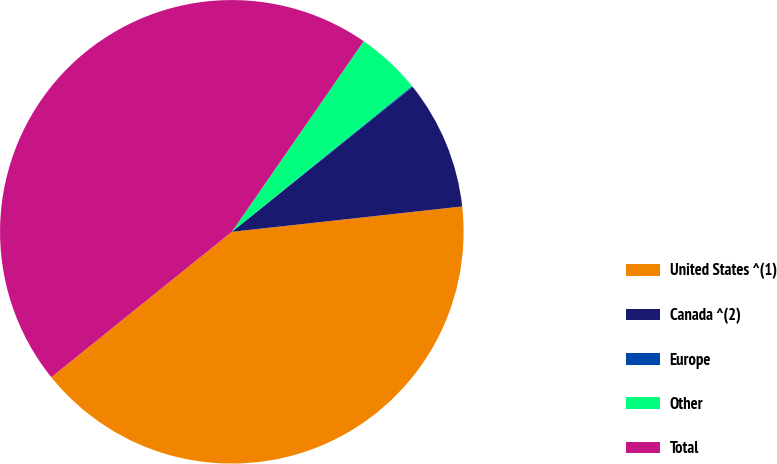Convert chart. <chart><loc_0><loc_0><loc_500><loc_500><pie_chart><fcel>United States ^(1)<fcel>Canada ^(2)<fcel>Europe<fcel>Other<fcel>Total<nl><fcel>40.96%<fcel>9.01%<fcel>0.07%<fcel>4.54%<fcel>45.43%<nl></chart> 